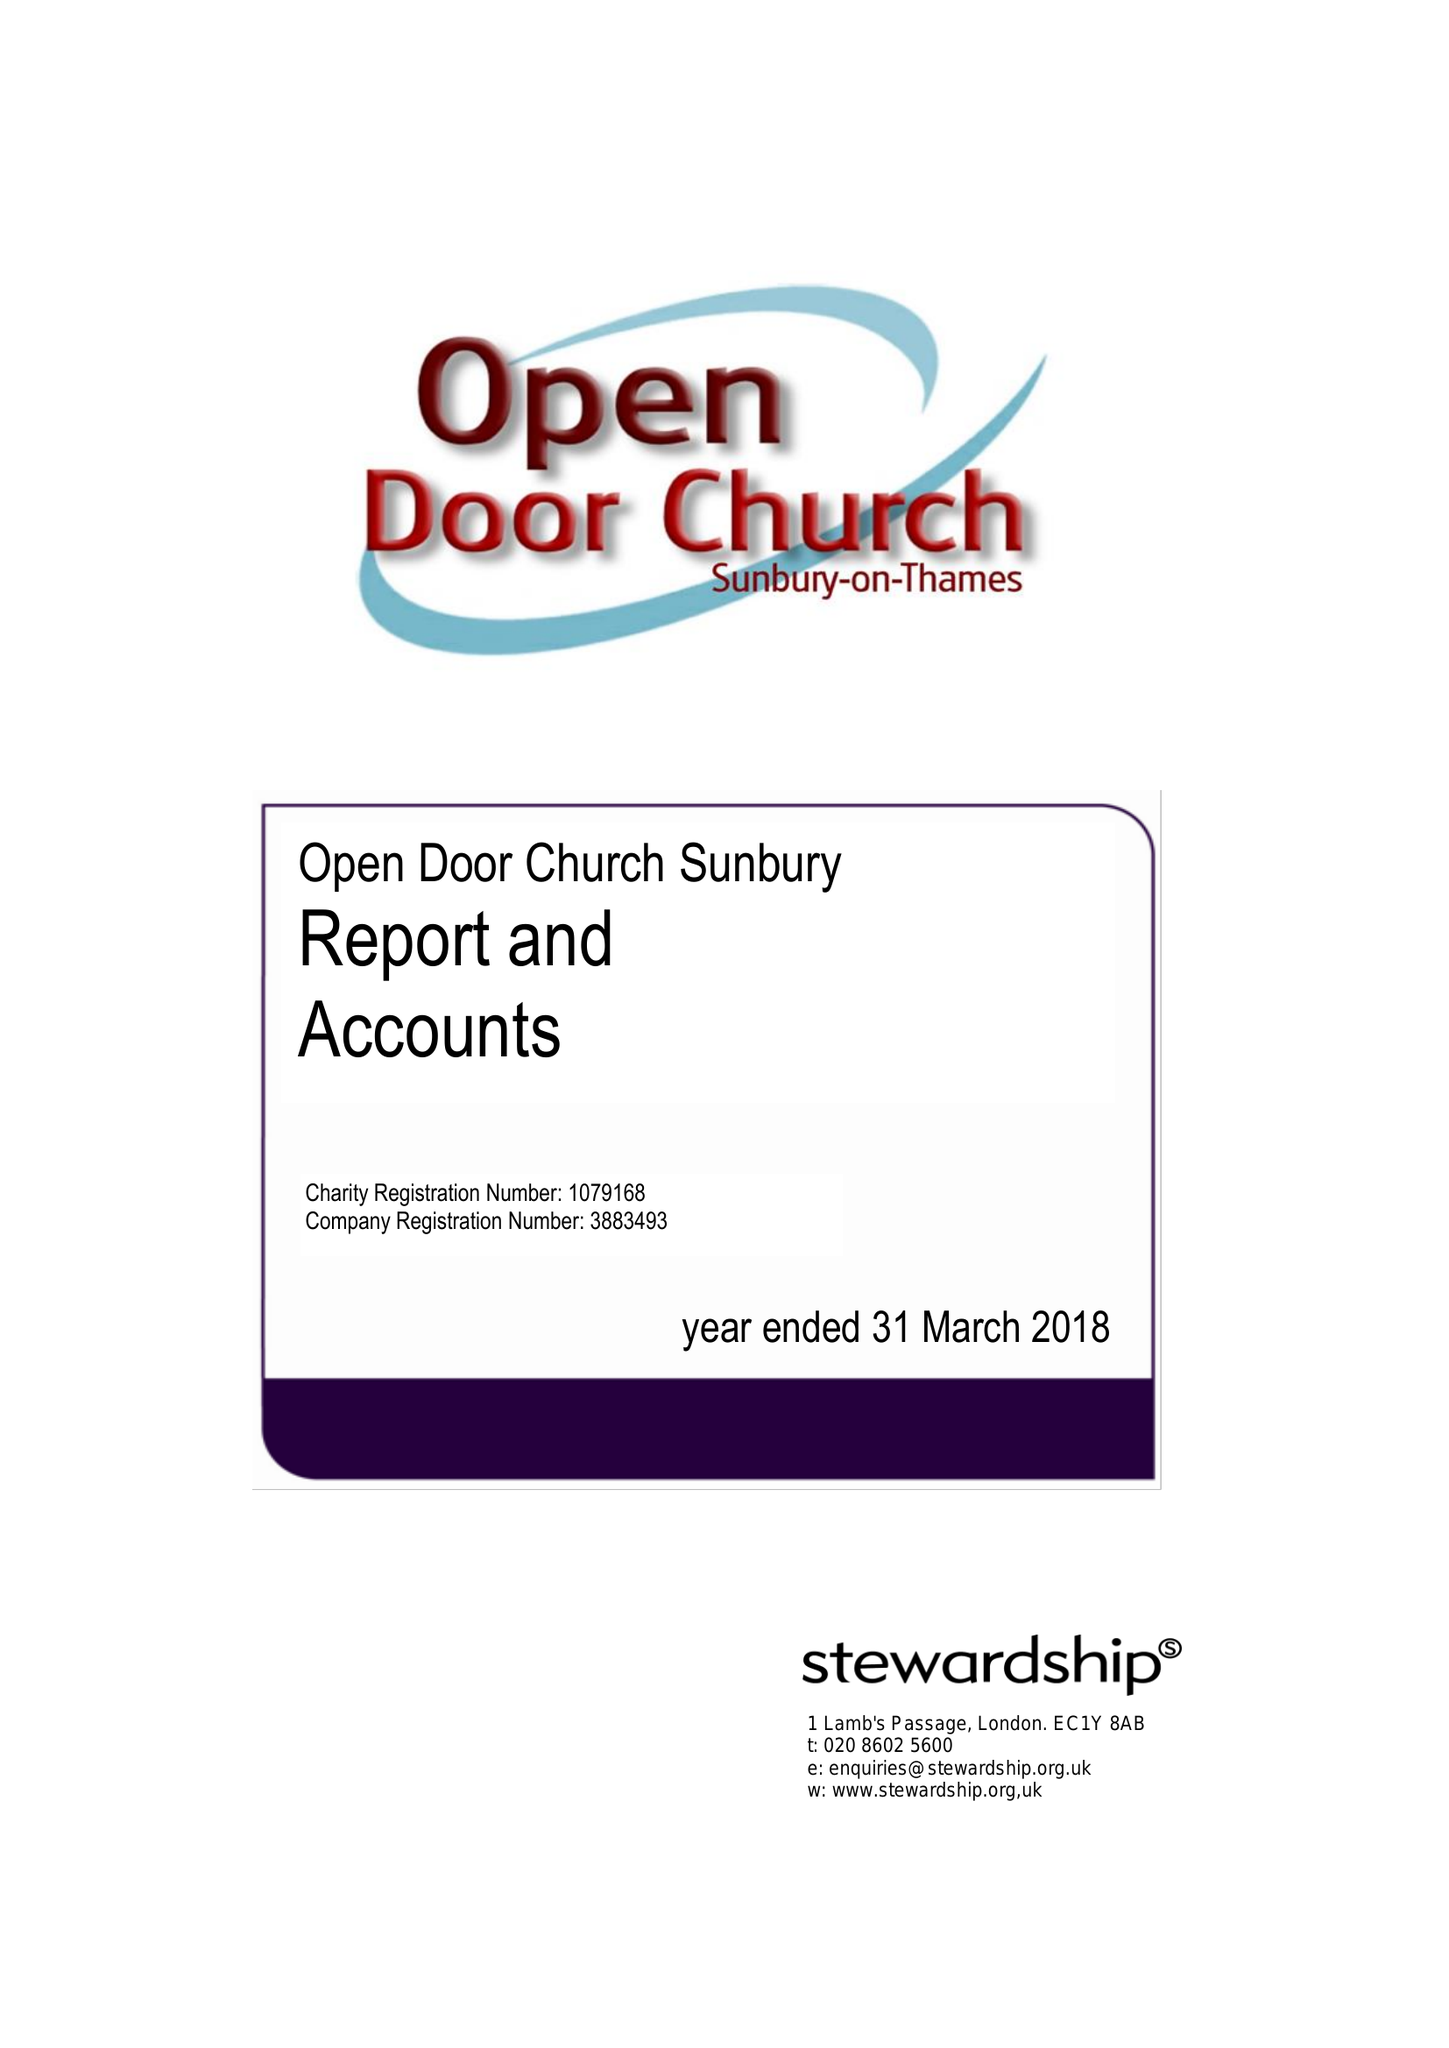What is the value for the address__post_town?
Answer the question using a single word or phrase. SUNBURY-ON-THAMES 